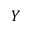Convert formula to latex. <formula><loc_0><loc_0><loc_500><loc_500>Y</formula> 